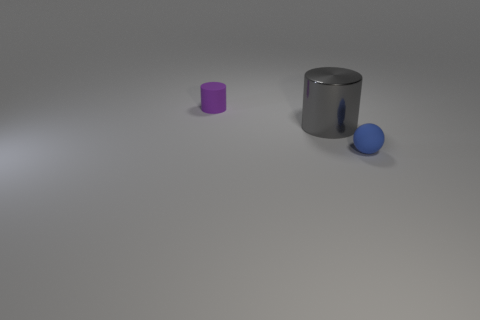Is there anything else that is the same material as the gray object?
Ensure brevity in your answer.  No. Are there the same number of small rubber things to the right of the rubber sphere and tiny objects that are left of the small purple matte thing?
Offer a very short reply. Yes. There is a rubber thing right of the rubber object that is to the left of the small sphere; how big is it?
Give a very brief answer. Small. Is there a gray object of the same size as the sphere?
Give a very brief answer. No. What is the color of the small ball that is made of the same material as the tiny cylinder?
Give a very brief answer. Blue. Are there fewer tiny balls than big cyan shiny cylinders?
Ensure brevity in your answer.  No. There is a object that is both on the right side of the matte cylinder and behind the blue sphere; what is its material?
Offer a terse response. Metal. Are there any tiny objects right of the small rubber thing that is behind the large object?
Provide a succinct answer. Yes. What number of tiny balls have the same color as the rubber cylinder?
Provide a short and direct response. 0. Are the small purple object and the blue object made of the same material?
Make the answer very short. Yes. 